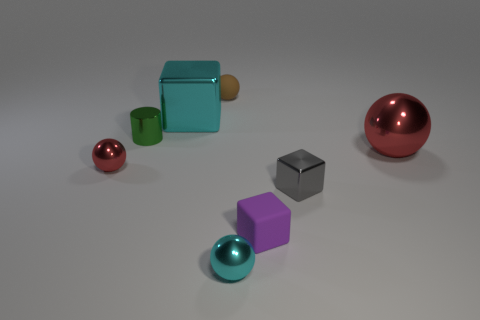What is the size of the other sphere that is the same color as the large ball?
Give a very brief answer. Small. There is a cyan metal thing that is in front of the big thing that is behind the big ball; what shape is it?
Keep it short and to the point. Sphere. Is there a big metal cube in front of the red thing that is on the left side of the red metal ball that is on the right side of the tiny green metallic object?
Your answer should be very brief. No. The matte cube that is the same size as the green metallic cylinder is what color?
Your answer should be compact. Purple. The small thing that is on the left side of the small purple rubber object and in front of the tiny gray cube has what shape?
Your answer should be compact. Sphere. There is a rubber object behind the purple matte block behind the cyan ball; what size is it?
Your response must be concise. Small. How many other cylinders are the same color as the cylinder?
Keep it short and to the point. 0. How many other things are there of the same size as the gray shiny block?
Provide a succinct answer. 5. What size is the cube that is on the left side of the small shiny cube and in front of the small cylinder?
Your answer should be very brief. Small. How many tiny brown things have the same shape as the small gray thing?
Your response must be concise. 0. 